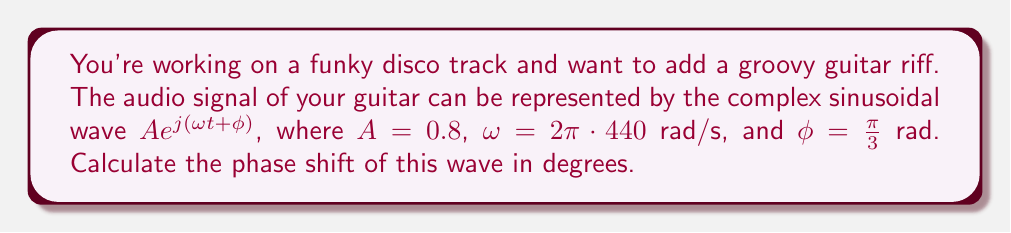Provide a solution to this math problem. To calculate the phase shift in degrees, we need to follow these steps:

1) In the given complex sinusoidal wave $A e^{j(\omega t + \phi)}$, the phase shift is represented by $\phi$.

2) We are given that $\phi = \frac{\pi}{3}$ rad.

3) To convert radians to degrees, we use the formula:
   $\text{degrees} = \text{radians} \cdot \frac{180^{\circ}}{\pi}$

4) Substituting our value:
   $$\text{degrees} = \frac{\pi}{3} \cdot \frac{180^{\circ}}{\pi}$$

5) The $\pi$ cancels out:
   $$\text{degrees} = \frac{1}{3} \cdot 180^{\circ}$$

6) Simplify:
   $$\text{degrees} = 60^{\circ}$$

Therefore, the phase shift of the complex sinusoidal wave is 60°.
Answer: 60° 